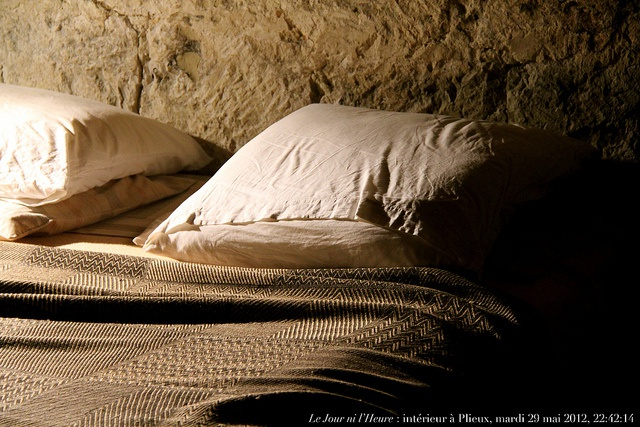Describe the objects in this image and their specific colors. I can see a bed in tan, black, gray, and ivory tones in this image. 